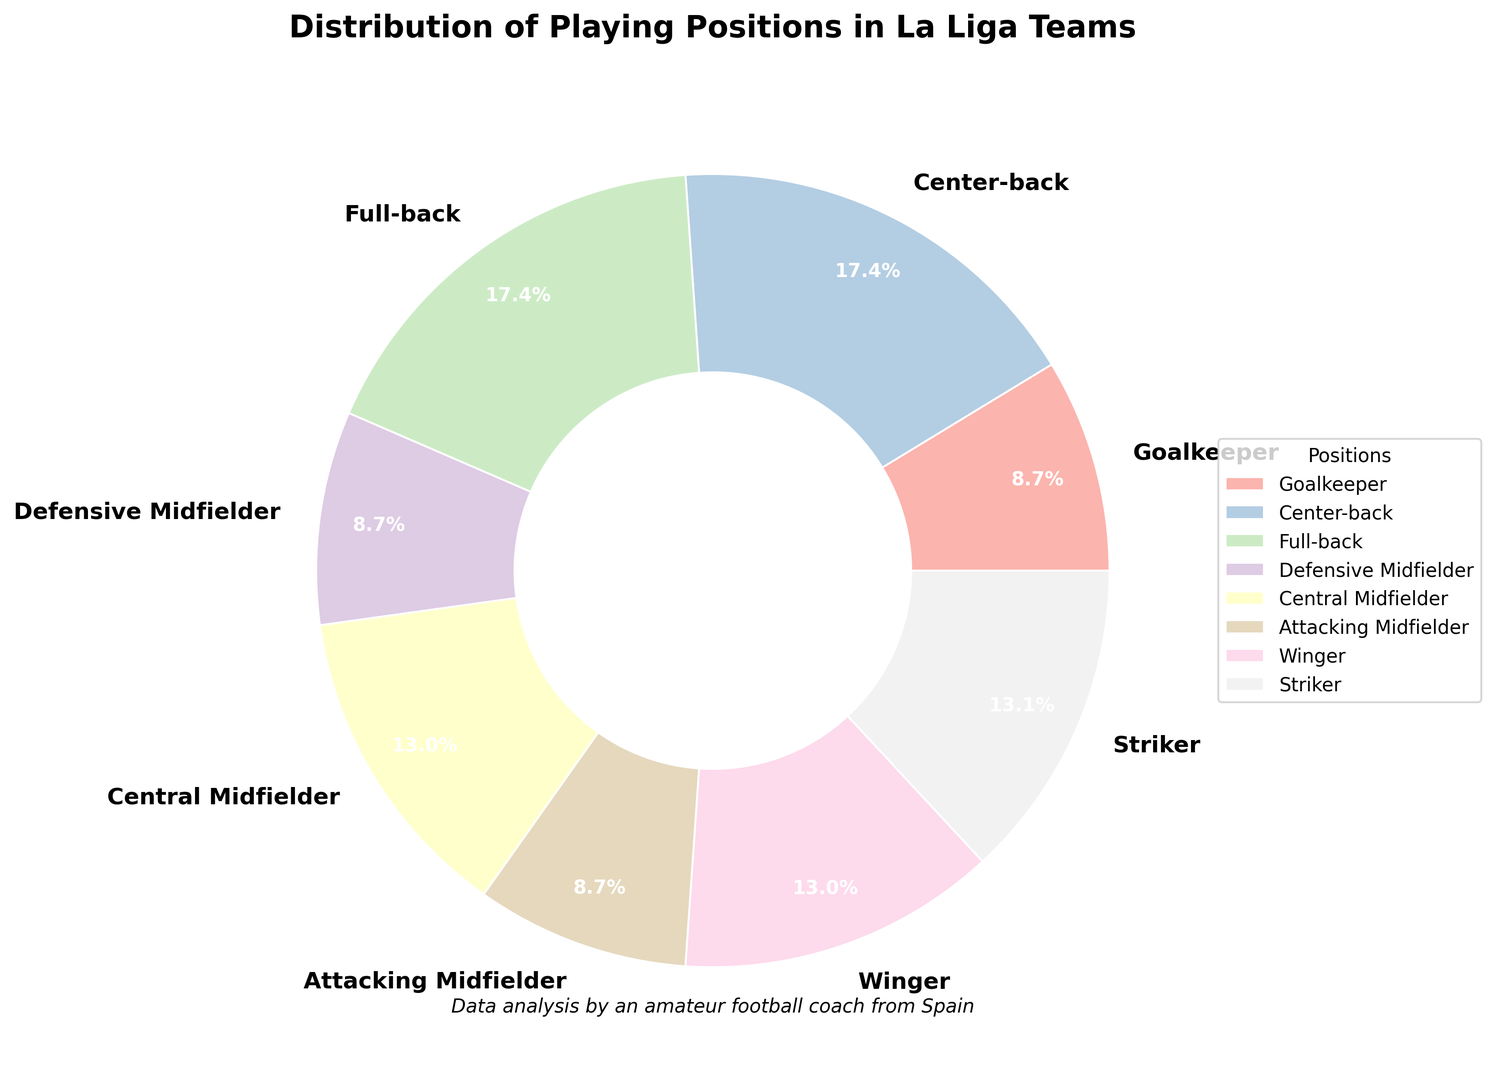What's the least common playing position in La Liga teams? By examining the pie chart, identify the position with the smallest percentage. There are three positions tied with the lowest percentage: Goalkeeper, Defensive Midfielder, and Attacking Midfielder, each with 8.7%.
Answer: Goalkeeper, Defensive Midfielder, Attacking Midfielder Which position has a higher percentage, Winger or Central Midfielder? Compare the percentages associated with Winger and Central Midfielder. Winger is 13.0% and Central Midfielder is also 13.0%.
Answer: Equal How many positions together make up more than 50% of the La Liga teams? Sum the percentages of the positions from largest to smallest until the cumulative percentage exceeds 50%. Center-back (17.4%) + Full-back (17.4%) + Striker (13.1%) = 47.9%, adding Winger (13.0%) makes it (47.9% + 13.0% = 60.9%). Thus, four positions.
Answer: 4 What is the total percentage of defensive positions (Goalkeeper, Center-back, Full-back, Defensive Midfielder)? Add the percentages of all defensive positions mentioned. Goalkeeper (8.7%) + Center-back (17.4%) + Full-back (17.4%) + Defensive Midfielder (8.7%) = 52.2%.
Answer: 52.2% Which position is visually represented with the largest wedge? Identify the position corresponding to the largest segment in the pie chart. The position with the largest percentage is Center-back (17.4%) and Full-back (17.4%).
Answer: Center-back, Full-back What is the difference in percentage between Center-back and Attacking Midfielder? Subtract the percentage of Attacking Midfielder from the percentage of Center-back. 17.4% - 8.7% = 8.7%.
Answer: 8.7% If the percentage of Full-backs increased by 2.6%, would it be the highest percentage position? Calculate the new percentage of Full-backs by adding 2.6% to the existing 17.4% and compare it with the highest percentage. 17.4% + 2.6% = 20%. It would then surpass the current highest percentage, which is 17.4%.
Answer: Yes Which position appears exactly three times in the top five positions by percentage? List the top five positions by percentage and count the occurrences. The top five positions are Center-back (17.4%), Full-back (17.4%), Striker (13.1%), Winger (13.0%), and Central Midfielder (13.0%). No position appears three times.
Answer: None What's the sum of the percentages of the attacking positions (Attacking Midfielder, Winger, Striker)? Add the percentages of all attacking positions mentioned. Attacking Midfielder (8.7%) + Winger (13.0%) + Striker (13.1%) = 34.8%.
Answer: 34.8% 